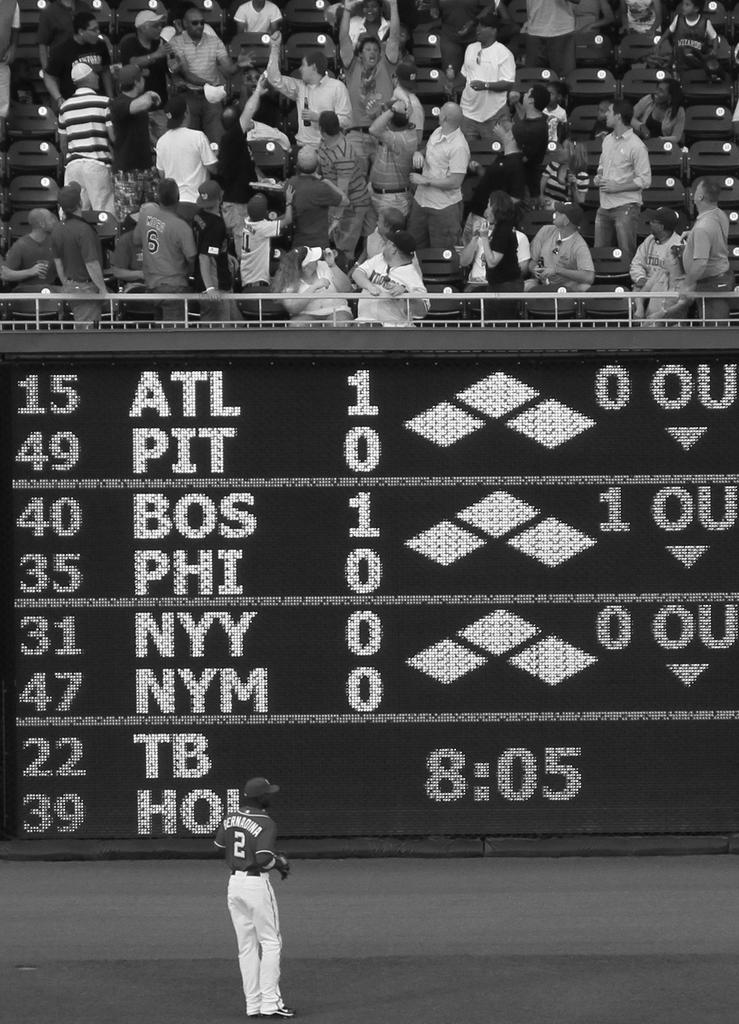<image>
Provide a brief description of the given image. A baseball player with 2 on his shirt in front of a score board. 